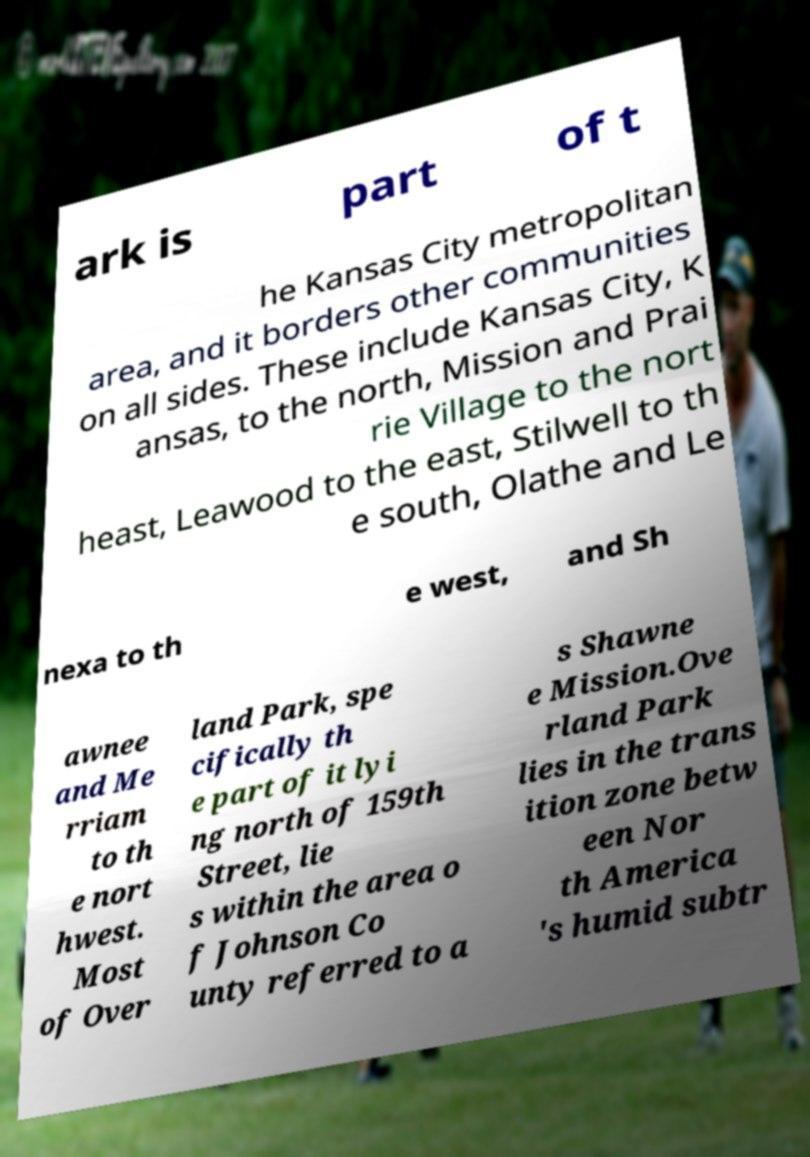Could you extract and type out the text from this image? ark is part of t he Kansas City metropolitan area, and it borders other communities on all sides. These include Kansas City, K ansas, to the north, Mission and Prai rie Village to the nort heast, Leawood to the east, Stilwell to th e south, Olathe and Le nexa to th e west, and Sh awnee and Me rriam to th e nort hwest. Most of Over land Park, spe cifically th e part of it lyi ng north of 159th Street, lie s within the area o f Johnson Co unty referred to a s Shawne e Mission.Ove rland Park lies in the trans ition zone betw een Nor th America 's humid subtr 